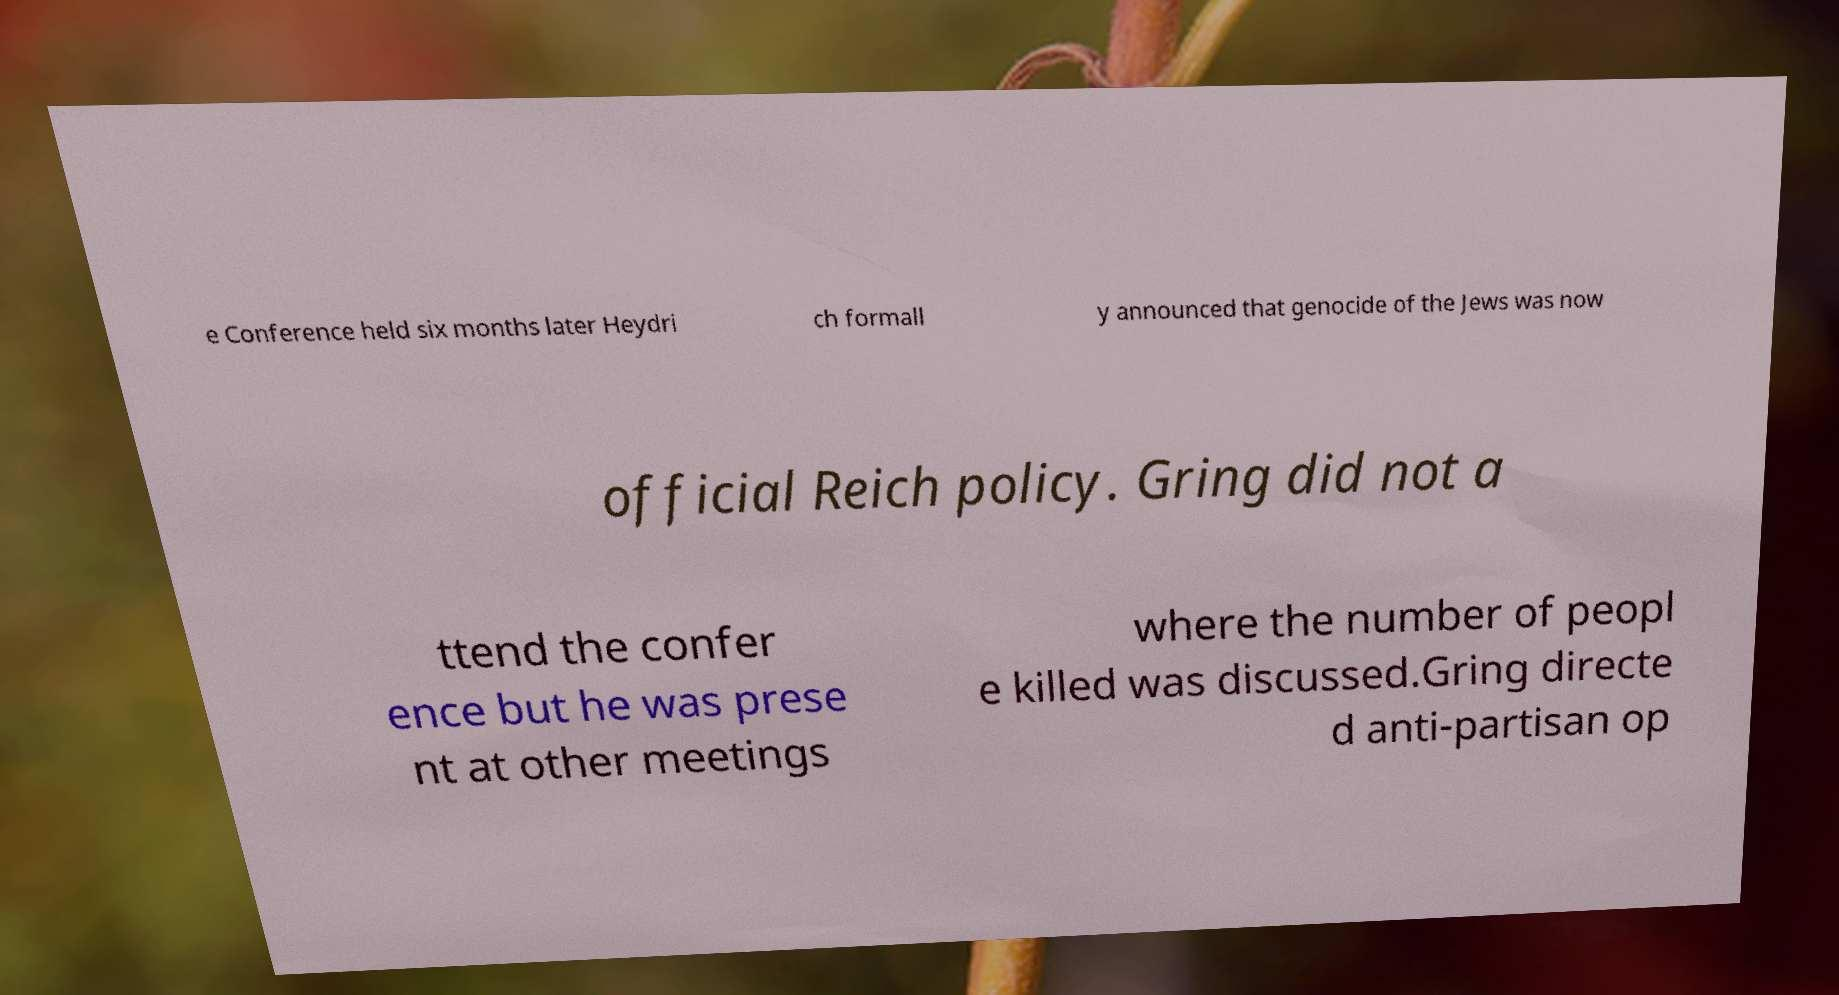Please read and relay the text visible in this image. What does it say? e Conference held six months later Heydri ch formall y announced that genocide of the Jews was now official Reich policy. Gring did not a ttend the confer ence but he was prese nt at other meetings where the number of peopl e killed was discussed.Gring directe d anti-partisan op 